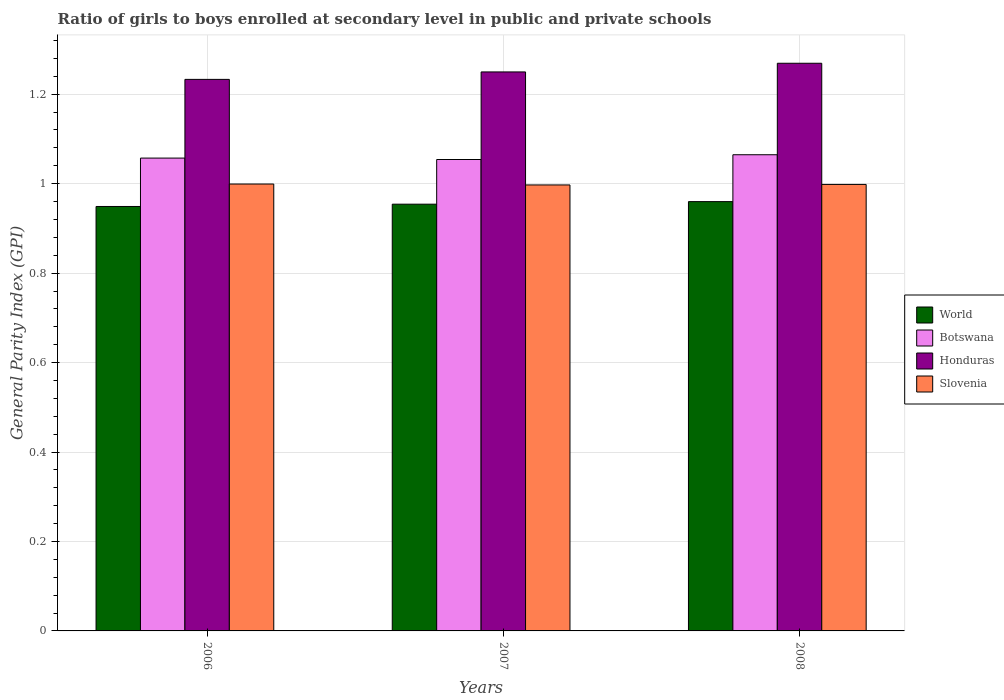How many different coloured bars are there?
Keep it short and to the point. 4. How many groups of bars are there?
Make the answer very short. 3. What is the label of the 3rd group of bars from the left?
Keep it short and to the point. 2008. What is the general parity index in World in 2007?
Provide a short and direct response. 0.95. Across all years, what is the maximum general parity index in World?
Your answer should be very brief. 0.96. Across all years, what is the minimum general parity index in World?
Provide a short and direct response. 0.95. In which year was the general parity index in Slovenia maximum?
Your response must be concise. 2006. What is the total general parity index in World in the graph?
Provide a short and direct response. 2.86. What is the difference between the general parity index in World in 2006 and that in 2007?
Provide a short and direct response. -0.01. What is the difference between the general parity index in Honduras in 2008 and the general parity index in World in 2006?
Give a very brief answer. 0.32. What is the average general parity index in Honduras per year?
Offer a terse response. 1.25. In the year 2006, what is the difference between the general parity index in World and general parity index in Botswana?
Keep it short and to the point. -0.11. In how many years, is the general parity index in Slovenia greater than 0.8400000000000001?
Your response must be concise. 3. What is the ratio of the general parity index in Honduras in 2006 to that in 2008?
Make the answer very short. 0.97. Is the general parity index in Botswana in 2007 less than that in 2008?
Your answer should be very brief. Yes. What is the difference between the highest and the second highest general parity index in Botswana?
Your answer should be compact. 0.01. What is the difference between the highest and the lowest general parity index in Honduras?
Make the answer very short. 0.04. Is it the case that in every year, the sum of the general parity index in Honduras and general parity index in World is greater than the sum of general parity index in Botswana and general parity index in Slovenia?
Your response must be concise. Yes. What does the 3rd bar from the left in 2006 represents?
Your response must be concise. Honduras. What does the 3rd bar from the right in 2006 represents?
Provide a short and direct response. Botswana. How many bars are there?
Your response must be concise. 12. Are all the bars in the graph horizontal?
Keep it short and to the point. No. How many years are there in the graph?
Your answer should be compact. 3. What is the difference between two consecutive major ticks on the Y-axis?
Give a very brief answer. 0.2. Does the graph contain any zero values?
Ensure brevity in your answer.  No. Does the graph contain grids?
Your response must be concise. Yes. Where does the legend appear in the graph?
Ensure brevity in your answer.  Center right. What is the title of the graph?
Your answer should be very brief. Ratio of girls to boys enrolled at secondary level in public and private schools. What is the label or title of the X-axis?
Your answer should be compact. Years. What is the label or title of the Y-axis?
Provide a succinct answer. General Parity Index (GPI). What is the General Parity Index (GPI) in World in 2006?
Ensure brevity in your answer.  0.95. What is the General Parity Index (GPI) of Botswana in 2006?
Ensure brevity in your answer.  1.06. What is the General Parity Index (GPI) of Honduras in 2006?
Your answer should be compact. 1.23. What is the General Parity Index (GPI) in Slovenia in 2006?
Your answer should be very brief. 1. What is the General Parity Index (GPI) of World in 2007?
Provide a succinct answer. 0.95. What is the General Parity Index (GPI) of Botswana in 2007?
Provide a succinct answer. 1.05. What is the General Parity Index (GPI) in Honduras in 2007?
Ensure brevity in your answer.  1.25. What is the General Parity Index (GPI) in Slovenia in 2007?
Your answer should be compact. 1. What is the General Parity Index (GPI) of World in 2008?
Your answer should be very brief. 0.96. What is the General Parity Index (GPI) in Botswana in 2008?
Keep it short and to the point. 1.06. What is the General Parity Index (GPI) of Honduras in 2008?
Your answer should be compact. 1.27. What is the General Parity Index (GPI) in Slovenia in 2008?
Your response must be concise. 1. Across all years, what is the maximum General Parity Index (GPI) of World?
Your answer should be very brief. 0.96. Across all years, what is the maximum General Parity Index (GPI) of Botswana?
Ensure brevity in your answer.  1.06. Across all years, what is the maximum General Parity Index (GPI) of Honduras?
Your answer should be very brief. 1.27. Across all years, what is the maximum General Parity Index (GPI) in Slovenia?
Provide a short and direct response. 1. Across all years, what is the minimum General Parity Index (GPI) in World?
Give a very brief answer. 0.95. Across all years, what is the minimum General Parity Index (GPI) of Botswana?
Provide a succinct answer. 1.05. Across all years, what is the minimum General Parity Index (GPI) in Honduras?
Your answer should be very brief. 1.23. Across all years, what is the minimum General Parity Index (GPI) of Slovenia?
Your answer should be very brief. 1. What is the total General Parity Index (GPI) in World in the graph?
Make the answer very short. 2.86. What is the total General Parity Index (GPI) of Botswana in the graph?
Provide a succinct answer. 3.18. What is the total General Parity Index (GPI) in Honduras in the graph?
Your answer should be very brief. 3.75. What is the total General Parity Index (GPI) of Slovenia in the graph?
Provide a succinct answer. 2.99. What is the difference between the General Parity Index (GPI) in World in 2006 and that in 2007?
Ensure brevity in your answer.  -0.01. What is the difference between the General Parity Index (GPI) in Botswana in 2006 and that in 2007?
Give a very brief answer. 0. What is the difference between the General Parity Index (GPI) in Honduras in 2006 and that in 2007?
Offer a very short reply. -0.02. What is the difference between the General Parity Index (GPI) of Slovenia in 2006 and that in 2007?
Keep it short and to the point. 0. What is the difference between the General Parity Index (GPI) of World in 2006 and that in 2008?
Provide a short and direct response. -0.01. What is the difference between the General Parity Index (GPI) in Botswana in 2006 and that in 2008?
Ensure brevity in your answer.  -0.01. What is the difference between the General Parity Index (GPI) of Honduras in 2006 and that in 2008?
Give a very brief answer. -0.04. What is the difference between the General Parity Index (GPI) in Slovenia in 2006 and that in 2008?
Offer a terse response. 0. What is the difference between the General Parity Index (GPI) of World in 2007 and that in 2008?
Keep it short and to the point. -0.01. What is the difference between the General Parity Index (GPI) in Botswana in 2007 and that in 2008?
Your response must be concise. -0.01. What is the difference between the General Parity Index (GPI) in Honduras in 2007 and that in 2008?
Provide a short and direct response. -0.02. What is the difference between the General Parity Index (GPI) of Slovenia in 2007 and that in 2008?
Provide a succinct answer. -0. What is the difference between the General Parity Index (GPI) in World in 2006 and the General Parity Index (GPI) in Botswana in 2007?
Offer a terse response. -0.1. What is the difference between the General Parity Index (GPI) in World in 2006 and the General Parity Index (GPI) in Honduras in 2007?
Ensure brevity in your answer.  -0.3. What is the difference between the General Parity Index (GPI) of World in 2006 and the General Parity Index (GPI) of Slovenia in 2007?
Provide a succinct answer. -0.05. What is the difference between the General Parity Index (GPI) in Botswana in 2006 and the General Parity Index (GPI) in Honduras in 2007?
Offer a terse response. -0.19. What is the difference between the General Parity Index (GPI) of Botswana in 2006 and the General Parity Index (GPI) of Slovenia in 2007?
Provide a succinct answer. 0.06. What is the difference between the General Parity Index (GPI) in Honduras in 2006 and the General Parity Index (GPI) in Slovenia in 2007?
Offer a very short reply. 0.24. What is the difference between the General Parity Index (GPI) in World in 2006 and the General Parity Index (GPI) in Botswana in 2008?
Your response must be concise. -0.12. What is the difference between the General Parity Index (GPI) in World in 2006 and the General Parity Index (GPI) in Honduras in 2008?
Provide a succinct answer. -0.32. What is the difference between the General Parity Index (GPI) in World in 2006 and the General Parity Index (GPI) in Slovenia in 2008?
Offer a very short reply. -0.05. What is the difference between the General Parity Index (GPI) of Botswana in 2006 and the General Parity Index (GPI) of Honduras in 2008?
Keep it short and to the point. -0.21. What is the difference between the General Parity Index (GPI) of Botswana in 2006 and the General Parity Index (GPI) of Slovenia in 2008?
Provide a short and direct response. 0.06. What is the difference between the General Parity Index (GPI) of Honduras in 2006 and the General Parity Index (GPI) of Slovenia in 2008?
Ensure brevity in your answer.  0.23. What is the difference between the General Parity Index (GPI) of World in 2007 and the General Parity Index (GPI) of Botswana in 2008?
Your answer should be very brief. -0.11. What is the difference between the General Parity Index (GPI) of World in 2007 and the General Parity Index (GPI) of Honduras in 2008?
Provide a short and direct response. -0.32. What is the difference between the General Parity Index (GPI) in World in 2007 and the General Parity Index (GPI) in Slovenia in 2008?
Offer a very short reply. -0.04. What is the difference between the General Parity Index (GPI) in Botswana in 2007 and the General Parity Index (GPI) in Honduras in 2008?
Give a very brief answer. -0.22. What is the difference between the General Parity Index (GPI) of Botswana in 2007 and the General Parity Index (GPI) of Slovenia in 2008?
Your answer should be very brief. 0.06. What is the difference between the General Parity Index (GPI) in Honduras in 2007 and the General Parity Index (GPI) in Slovenia in 2008?
Offer a terse response. 0.25. What is the average General Parity Index (GPI) of World per year?
Keep it short and to the point. 0.95. What is the average General Parity Index (GPI) in Botswana per year?
Your answer should be very brief. 1.06. What is the average General Parity Index (GPI) of Honduras per year?
Offer a very short reply. 1.25. In the year 2006, what is the difference between the General Parity Index (GPI) of World and General Parity Index (GPI) of Botswana?
Your answer should be compact. -0.11. In the year 2006, what is the difference between the General Parity Index (GPI) of World and General Parity Index (GPI) of Honduras?
Your response must be concise. -0.28. In the year 2006, what is the difference between the General Parity Index (GPI) of World and General Parity Index (GPI) of Slovenia?
Your answer should be very brief. -0.05. In the year 2006, what is the difference between the General Parity Index (GPI) of Botswana and General Parity Index (GPI) of Honduras?
Offer a very short reply. -0.18. In the year 2006, what is the difference between the General Parity Index (GPI) of Botswana and General Parity Index (GPI) of Slovenia?
Give a very brief answer. 0.06. In the year 2006, what is the difference between the General Parity Index (GPI) in Honduras and General Parity Index (GPI) in Slovenia?
Your response must be concise. 0.23. In the year 2007, what is the difference between the General Parity Index (GPI) of World and General Parity Index (GPI) of Botswana?
Make the answer very short. -0.1. In the year 2007, what is the difference between the General Parity Index (GPI) in World and General Parity Index (GPI) in Honduras?
Provide a short and direct response. -0.3. In the year 2007, what is the difference between the General Parity Index (GPI) of World and General Parity Index (GPI) of Slovenia?
Provide a succinct answer. -0.04. In the year 2007, what is the difference between the General Parity Index (GPI) in Botswana and General Parity Index (GPI) in Honduras?
Keep it short and to the point. -0.2. In the year 2007, what is the difference between the General Parity Index (GPI) in Botswana and General Parity Index (GPI) in Slovenia?
Give a very brief answer. 0.06. In the year 2007, what is the difference between the General Parity Index (GPI) in Honduras and General Parity Index (GPI) in Slovenia?
Give a very brief answer. 0.25. In the year 2008, what is the difference between the General Parity Index (GPI) in World and General Parity Index (GPI) in Botswana?
Make the answer very short. -0.1. In the year 2008, what is the difference between the General Parity Index (GPI) of World and General Parity Index (GPI) of Honduras?
Offer a very short reply. -0.31. In the year 2008, what is the difference between the General Parity Index (GPI) of World and General Parity Index (GPI) of Slovenia?
Your answer should be compact. -0.04. In the year 2008, what is the difference between the General Parity Index (GPI) of Botswana and General Parity Index (GPI) of Honduras?
Give a very brief answer. -0.2. In the year 2008, what is the difference between the General Parity Index (GPI) in Botswana and General Parity Index (GPI) in Slovenia?
Provide a short and direct response. 0.07. In the year 2008, what is the difference between the General Parity Index (GPI) of Honduras and General Parity Index (GPI) of Slovenia?
Give a very brief answer. 0.27. What is the ratio of the General Parity Index (GPI) in World in 2006 to that in 2007?
Your response must be concise. 0.99. What is the ratio of the General Parity Index (GPI) of Honduras in 2006 to that in 2007?
Your response must be concise. 0.99. What is the ratio of the General Parity Index (GPI) of Slovenia in 2006 to that in 2007?
Your answer should be very brief. 1. What is the ratio of the General Parity Index (GPI) in World in 2006 to that in 2008?
Make the answer very short. 0.99. What is the ratio of the General Parity Index (GPI) in Botswana in 2006 to that in 2008?
Offer a very short reply. 0.99. What is the ratio of the General Parity Index (GPI) of Honduras in 2006 to that in 2008?
Your answer should be compact. 0.97. What is the ratio of the General Parity Index (GPI) of Slovenia in 2006 to that in 2008?
Make the answer very short. 1. What is the ratio of the General Parity Index (GPI) in Honduras in 2007 to that in 2008?
Ensure brevity in your answer.  0.98. What is the ratio of the General Parity Index (GPI) in Slovenia in 2007 to that in 2008?
Your answer should be very brief. 1. What is the difference between the highest and the second highest General Parity Index (GPI) of World?
Provide a short and direct response. 0.01. What is the difference between the highest and the second highest General Parity Index (GPI) of Botswana?
Provide a succinct answer. 0.01. What is the difference between the highest and the second highest General Parity Index (GPI) in Honduras?
Provide a succinct answer. 0.02. What is the difference between the highest and the second highest General Parity Index (GPI) of Slovenia?
Provide a succinct answer. 0. What is the difference between the highest and the lowest General Parity Index (GPI) of World?
Your answer should be very brief. 0.01. What is the difference between the highest and the lowest General Parity Index (GPI) in Botswana?
Your response must be concise. 0.01. What is the difference between the highest and the lowest General Parity Index (GPI) in Honduras?
Provide a short and direct response. 0.04. What is the difference between the highest and the lowest General Parity Index (GPI) in Slovenia?
Keep it short and to the point. 0. 